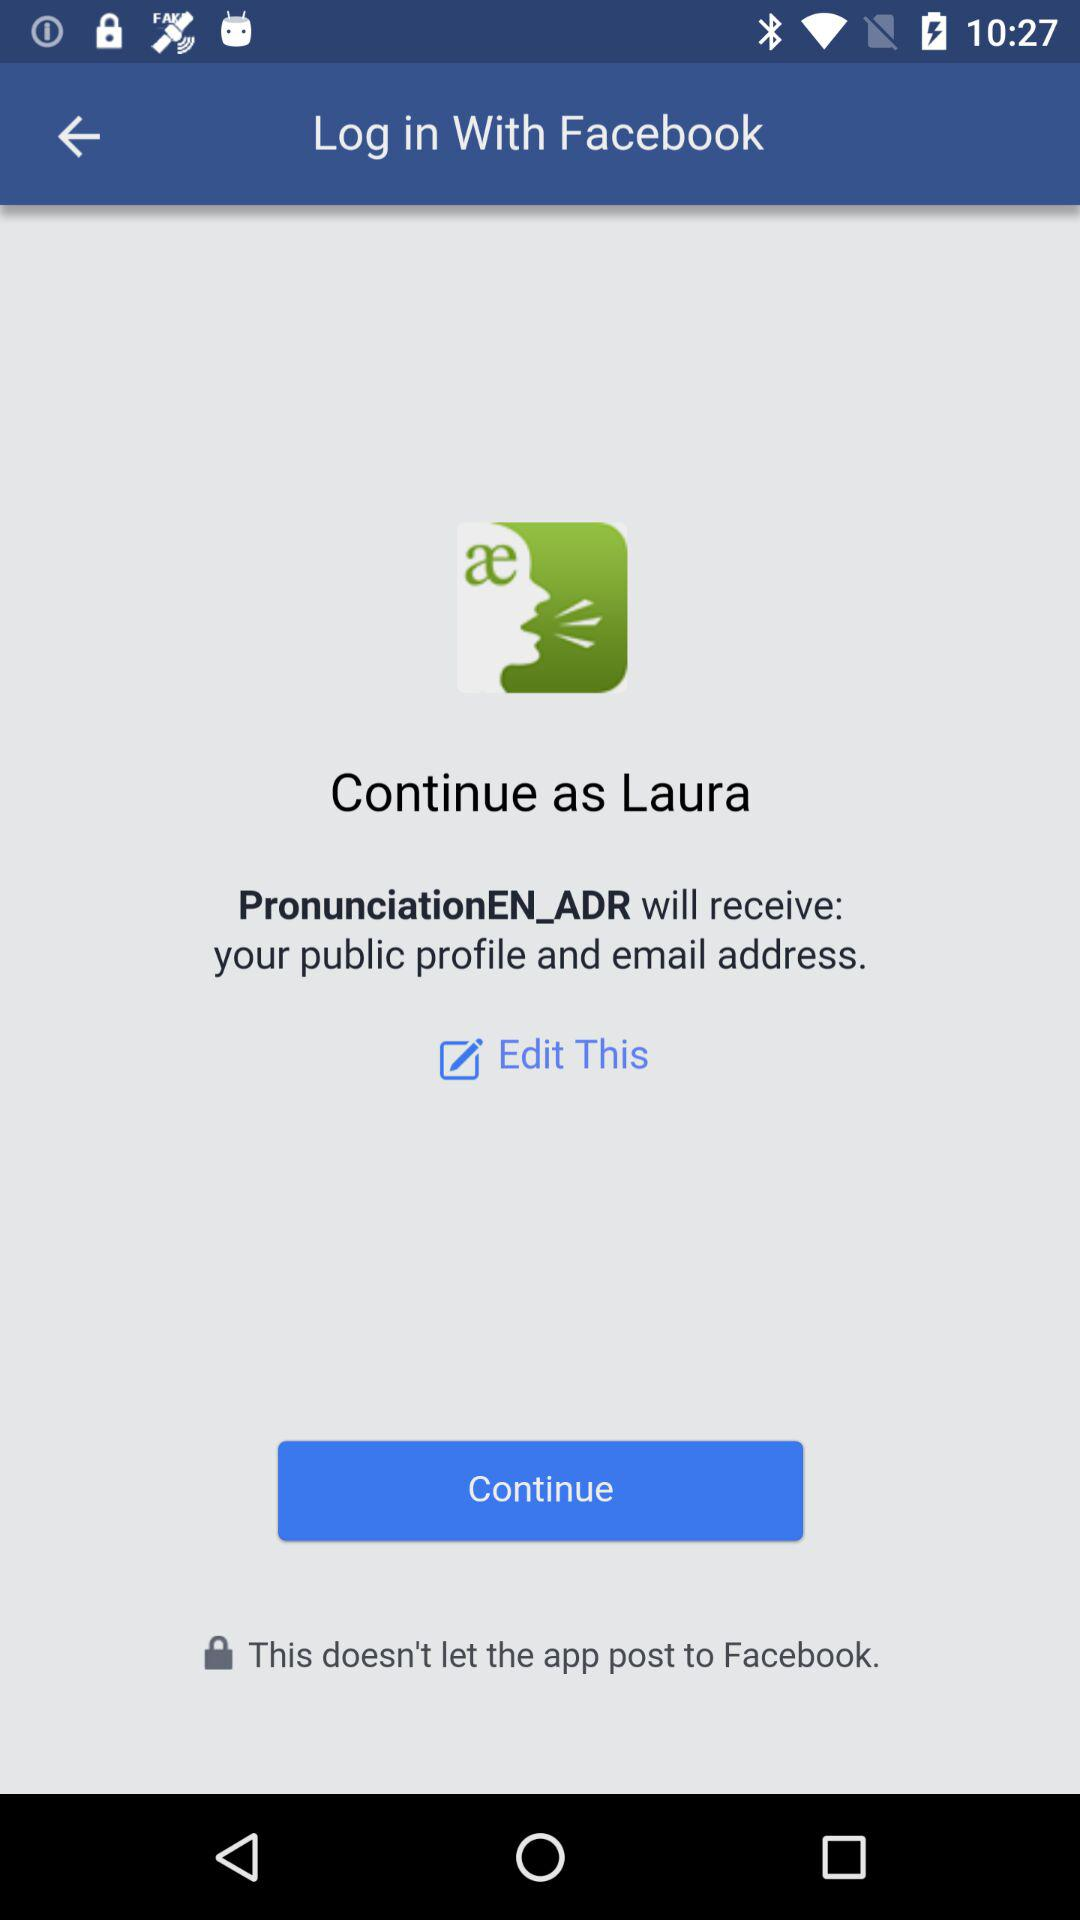Which information will "PronunciationEN_ADR" receive? "PronunciationEN_ADR" will receive your public profile and email address information. 